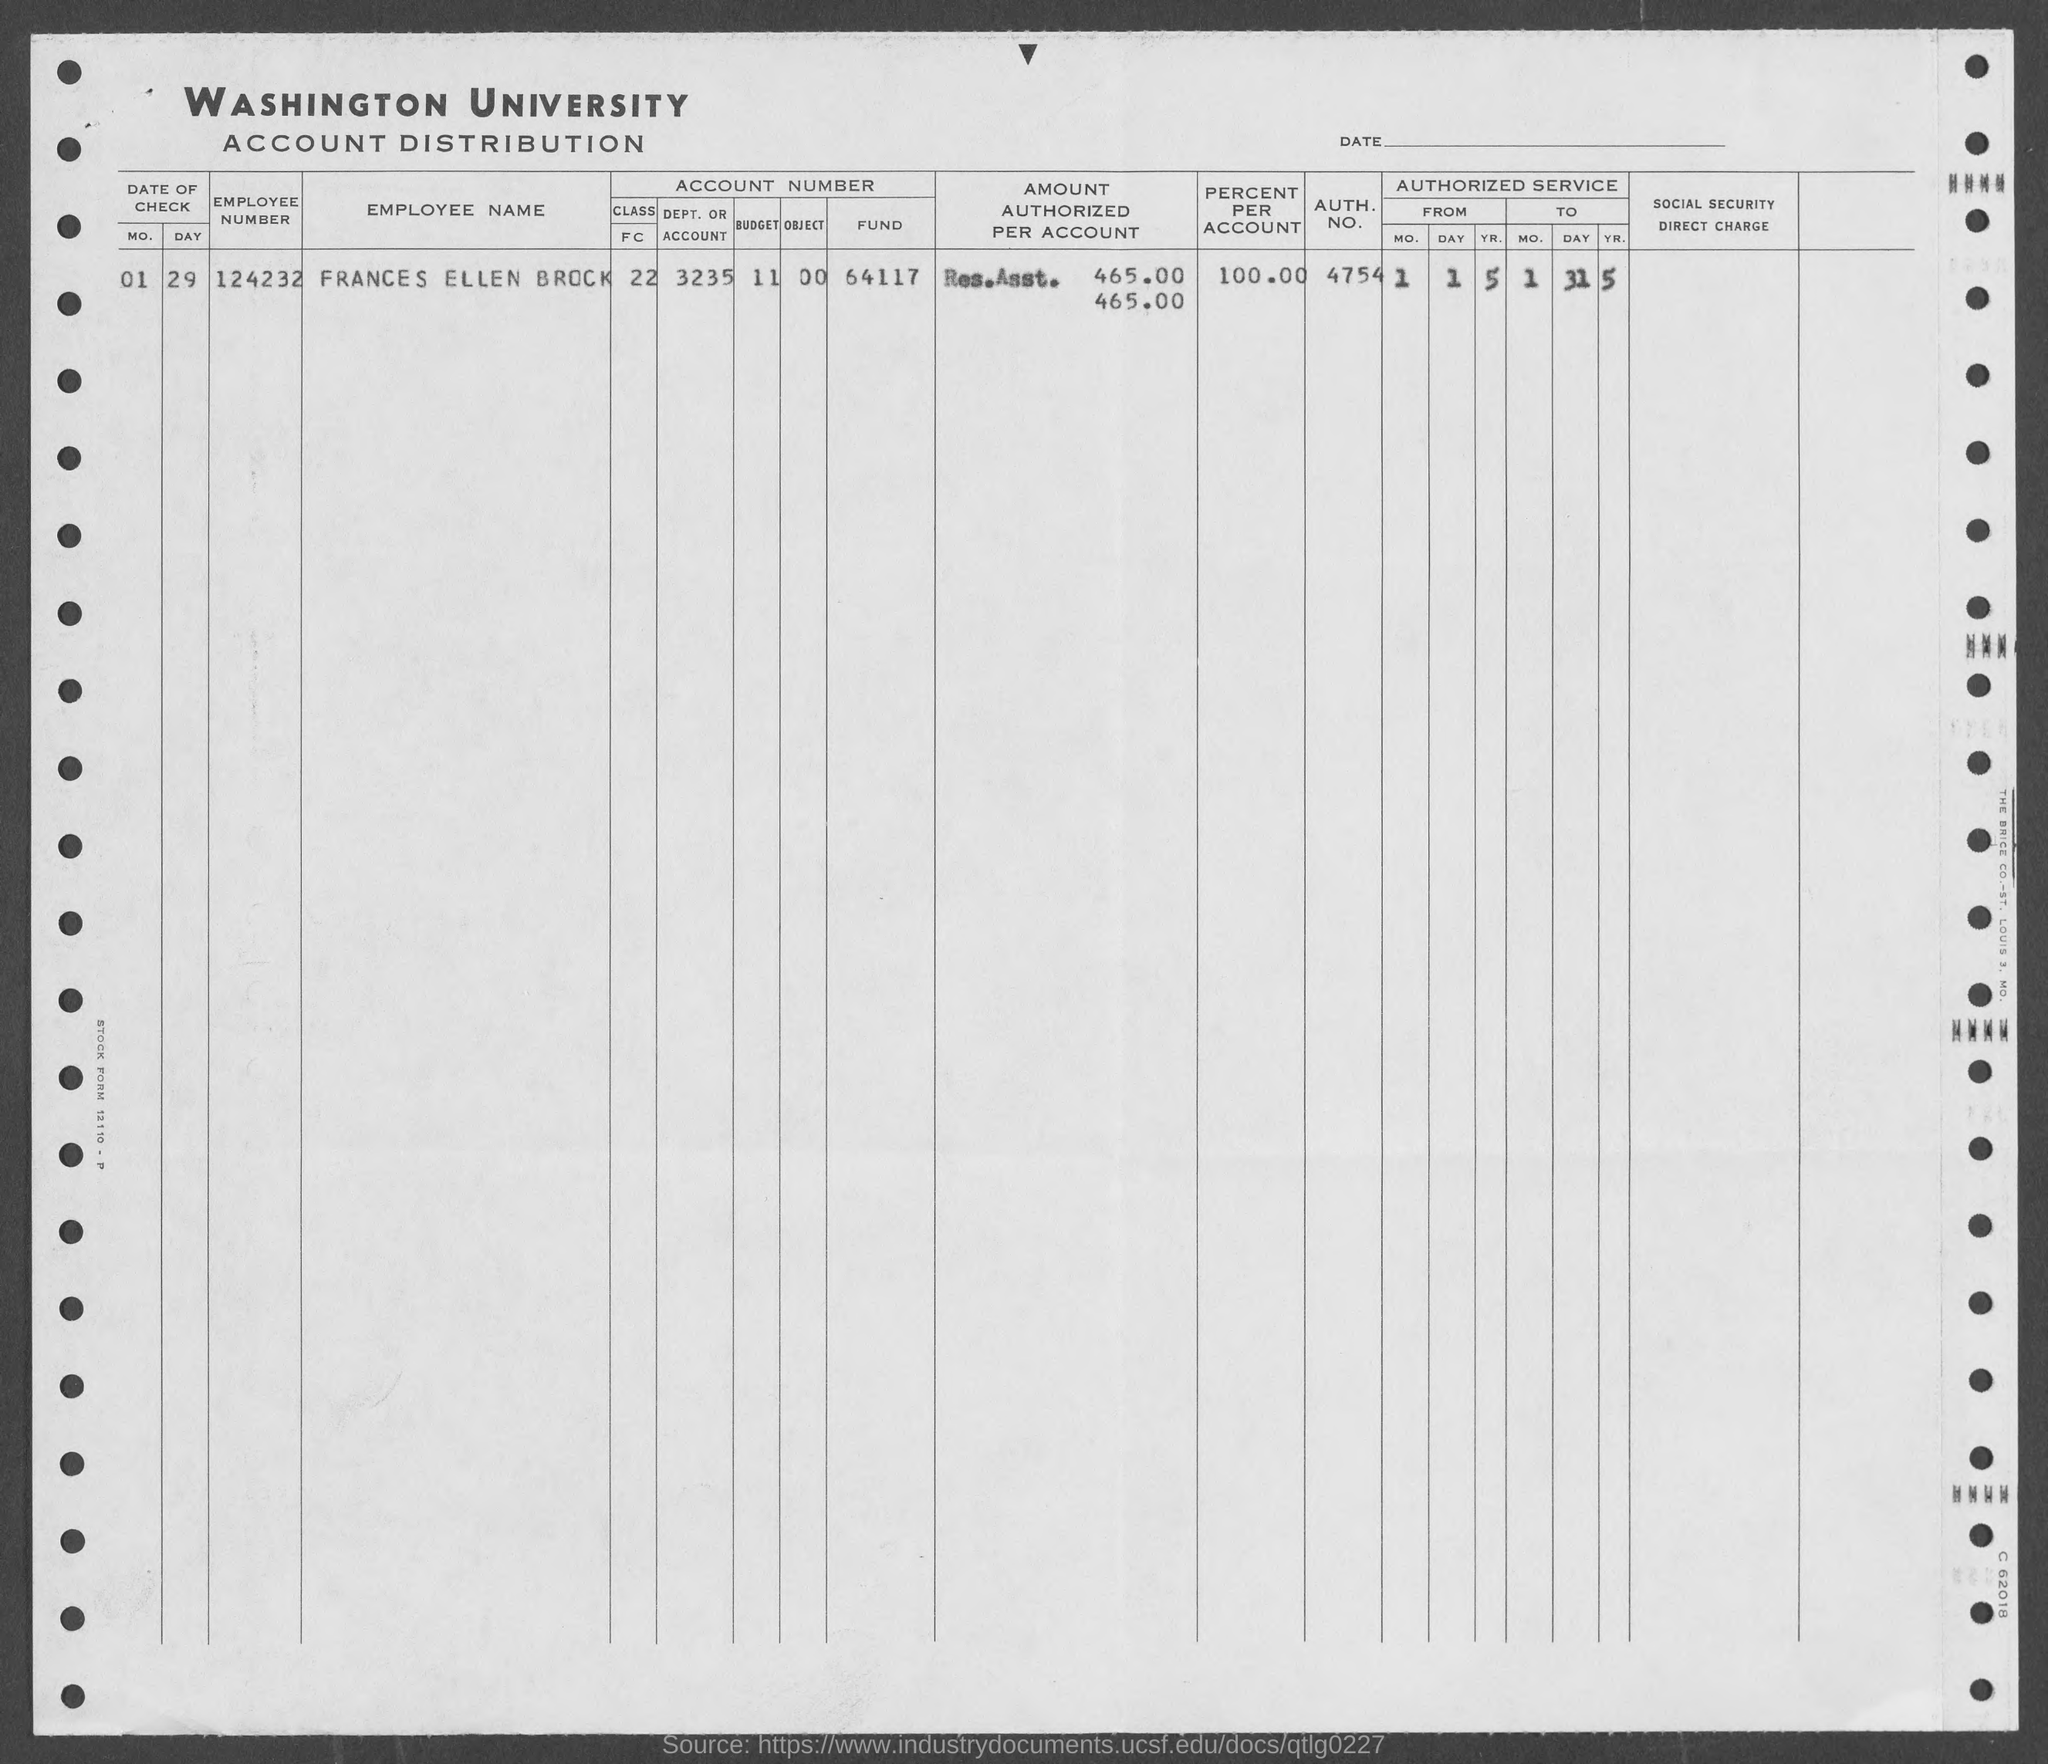Identify some key points in this picture. Frances Ellen Brock has 100% of the account. The employee number of Frances Ellen Brock is 124232. What is the authorization number for Frances Ellen Brock? 4754... 